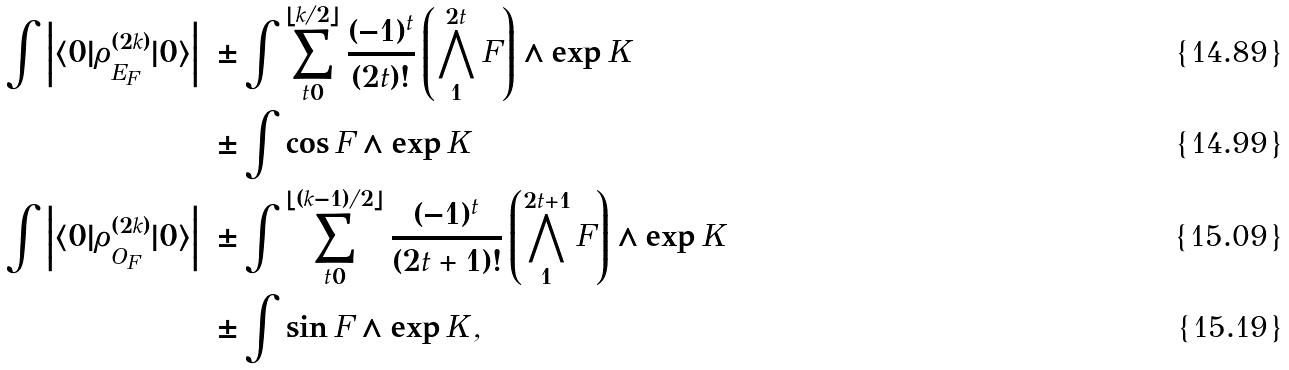Convert formula to latex. <formula><loc_0><loc_0><loc_500><loc_500>\int \left | \langle 0 | \rho ^ { ( 2 k ) } _ { E _ { F } } | 0 \rangle \right | & = \pm \int \sum _ { t = 0 } ^ { \lfloor k / 2 \rfloor } \frac { ( - 1 ) ^ { t } } { ( 2 t ) ! } \left ( \bigwedge _ { 1 } ^ { 2 t } F \right ) \wedge \exp K \\ & = \pm \int \cos F \wedge \exp K \, \\ \int \left | \langle 0 | \rho ^ { ( 2 k ) } _ { O _ { F } } | 0 \rangle \right | & = \pm \int \sum _ { t = 0 } ^ { \lfloor ( k - 1 ) / 2 \rfloor } \frac { ( - 1 ) ^ { t } } { ( 2 t + 1 ) ! } \left ( \bigwedge _ { 1 } ^ { 2 t + 1 } F \right ) \wedge \exp K \\ & = \pm \int \sin F \wedge \exp K \, ,</formula> 